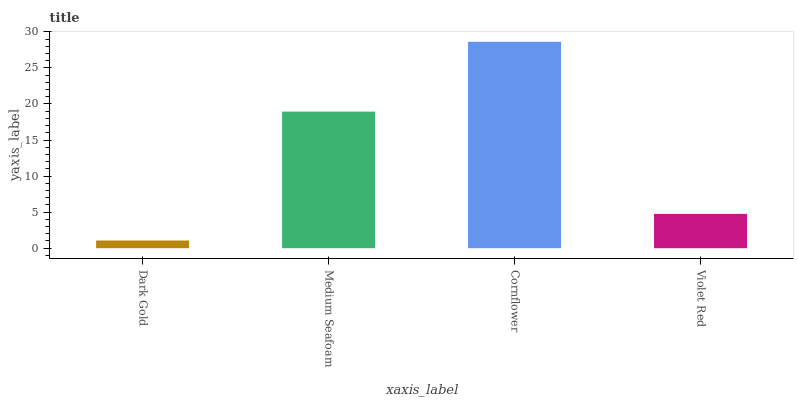Is Dark Gold the minimum?
Answer yes or no. Yes. Is Cornflower the maximum?
Answer yes or no. Yes. Is Medium Seafoam the minimum?
Answer yes or no. No. Is Medium Seafoam the maximum?
Answer yes or no. No. Is Medium Seafoam greater than Dark Gold?
Answer yes or no. Yes. Is Dark Gold less than Medium Seafoam?
Answer yes or no. Yes. Is Dark Gold greater than Medium Seafoam?
Answer yes or no. No. Is Medium Seafoam less than Dark Gold?
Answer yes or no. No. Is Medium Seafoam the high median?
Answer yes or no. Yes. Is Violet Red the low median?
Answer yes or no. Yes. Is Cornflower the high median?
Answer yes or no. No. Is Medium Seafoam the low median?
Answer yes or no. No. 